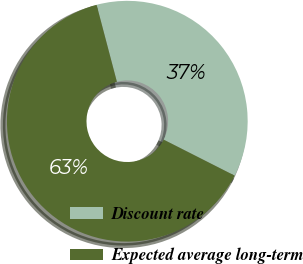Convert chart. <chart><loc_0><loc_0><loc_500><loc_500><pie_chart><fcel>Discount rate<fcel>Expected average long-term<nl><fcel>36.57%<fcel>63.43%<nl></chart> 